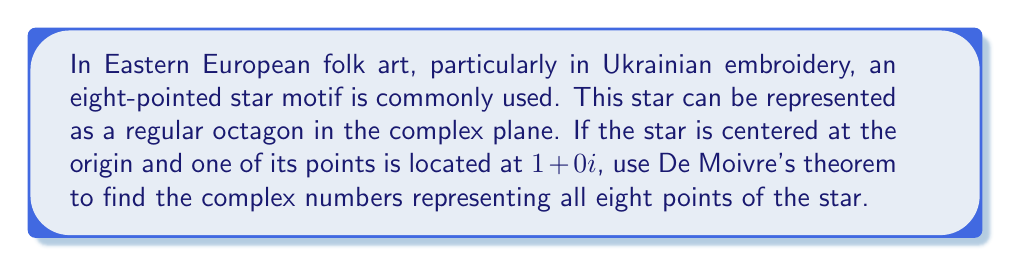Give your solution to this math problem. Let's approach this step-by-step:

1) First, we need to understand what De Moivre's theorem states. For any complex number in polar form $r(\cos\theta + i\sin\theta)$ and any integer $n$:

   $$[r(\cos\theta + i\sin\theta)]^n = r^n(\cos(n\theta) + i\sin(n\theta))$$

2) In our case, we're dealing with a regular octagon, which means the angle between each point is $\frac{2\pi}{8} = \frac{\pi}{4}$ radians or 45°.

3) We can represent each point of the octagon as:

   $$z_k = \cos(\frac{k\pi}{4}) + i\sin(\frac{k\pi}{4})$$

   where $k = 0, 1, 2, ..., 7$

4) This is equivalent to:

   $$z_k = (\cos(\frac{\pi}{4}) + i\sin(\frac{\pi}{4}))^k$$

5) We can calculate this using De Moivre's theorem:

   $$z_k = (\frac{\sqrt{2}}{2} + i\frac{\sqrt{2}}{2})^k$$

6) Now, let's calculate each point:

   For $k = 0$: $z_0 = 1 + 0i$
   For $k = 1$: $z_1 = \frac{\sqrt{2}}{2} + i\frac{\sqrt{2}}{2}$
   For $k = 2$: $z_2 = 0 + i$
   For $k = 3$: $z_3 = -\frac{\sqrt{2}}{2} + i\frac{\sqrt{2}}{2}$
   For $k = 4$: $z_4 = -1 + 0i$
   For $k = 5$: $z_5 = -\frac{\sqrt{2}}{2} - i\frac{\sqrt{2}}{2}$
   For $k = 6$: $z_6 = 0 - i$
   For $k = 7$: $z_7 = \frac{\sqrt{2}}{2} - i\frac{\sqrt{2}}{2}$

These eight complex numbers represent the points of the Ukrainian embroidery star motif in the complex plane.
Answer: The eight points of the star are represented by the complex numbers:

$z_0 = 1 + 0i$
$z_1 = \frac{\sqrt{2}}{2} + i\frac{\sqrt{2}}{2}$
$z_2 = 0 + i$
$z_3 = -\frac{\sqrt{2}}{2} + i\frac{\sqrt{2}}{2}$
$z_4 = -1 + 0i$
$z_5 = -\frac{\sqrt{2}}{2} - i\frac{\sqrt{2}}{2}$
$z_6 = 0 - i$
$z_7 = \frac{\sqrt{2}}{2} - i\frac{\sqrt{2}}{2}$ 